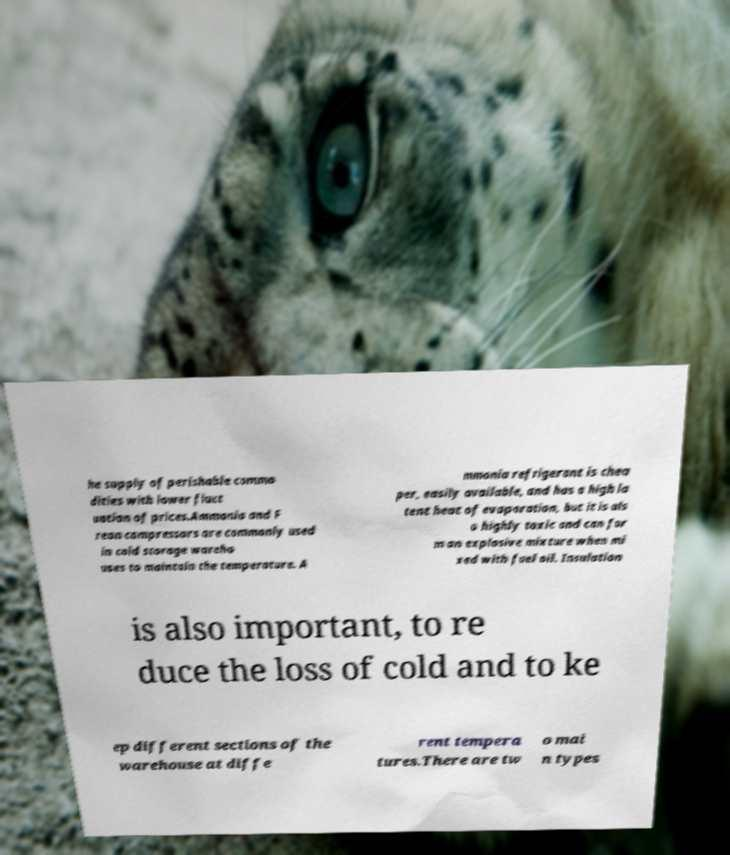Could you assist in decoding the text presented in this image and type it out clearly? he supply of perishable commo dities with lower fluct uation of prices.Ammonia and F reon compressors are commonly used in cold storage wareho uses to maintain the temperature. A mmonia refrigerant is chea per, easily available, and has a high la tent heat of evaporation, but it is als o highly toxic and can for m an explosive mixture when mi xed with fuel oil. Insulation is also important, to re duce the loss of cold and to ke ep different sections of the warehouse at diffe rent tempera tures.There are tw o mai n types 